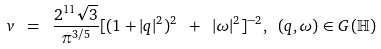<formula> <loc_0><loc_0><loc_500><loc_500>v \ = \ \frac { 2 ^ { 1 1 } \sqrt { 3 } } { \pi ^ { 3 / 5 } } [ ( 1 + | q | ^ { 2 } ) ^ { 2 } \ + \ | \omega | ^ { 2 } ] ^ { - 2 } , \ ( q , \omega ) \in G \, ( \mathbb { H } )</formula> 